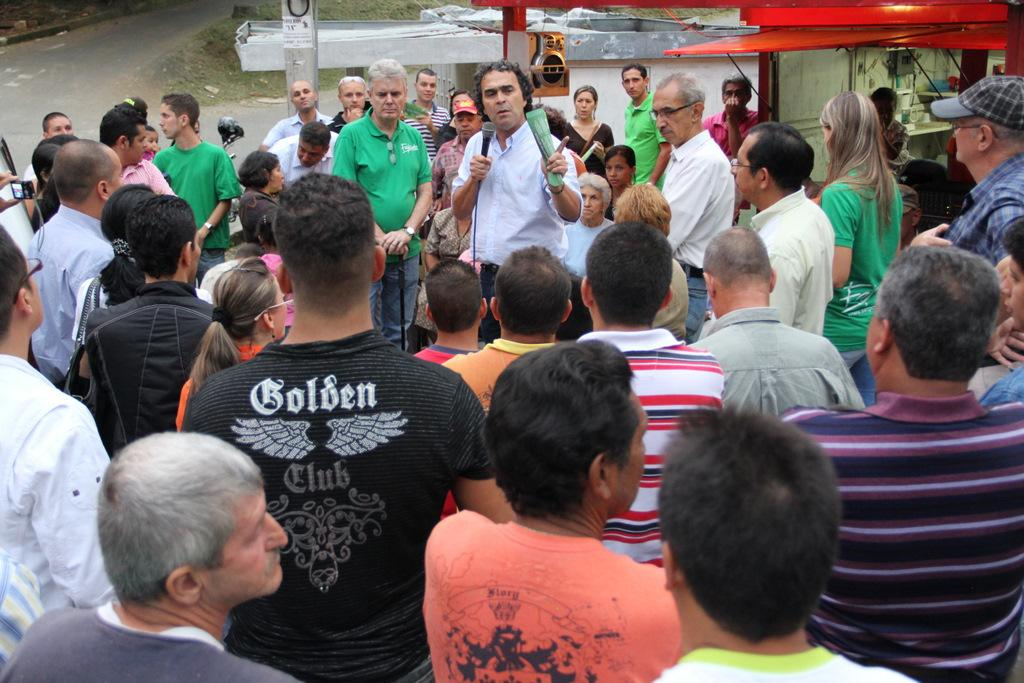What is the main subject of the image? The main subject of the image is a crowd. Can you describe the person in the center of the crowd? The person in the center is wearing a white shirt, holding a paper and a mic. What can be seen in the background of the image? There is a road, a pole, a speaker, and buildings in the background of the image. What type of door can be seen in the image? There is no door present in the image. What color is the canvas that the person in the center is painting on? There is no canvas or painting activity in the image. 